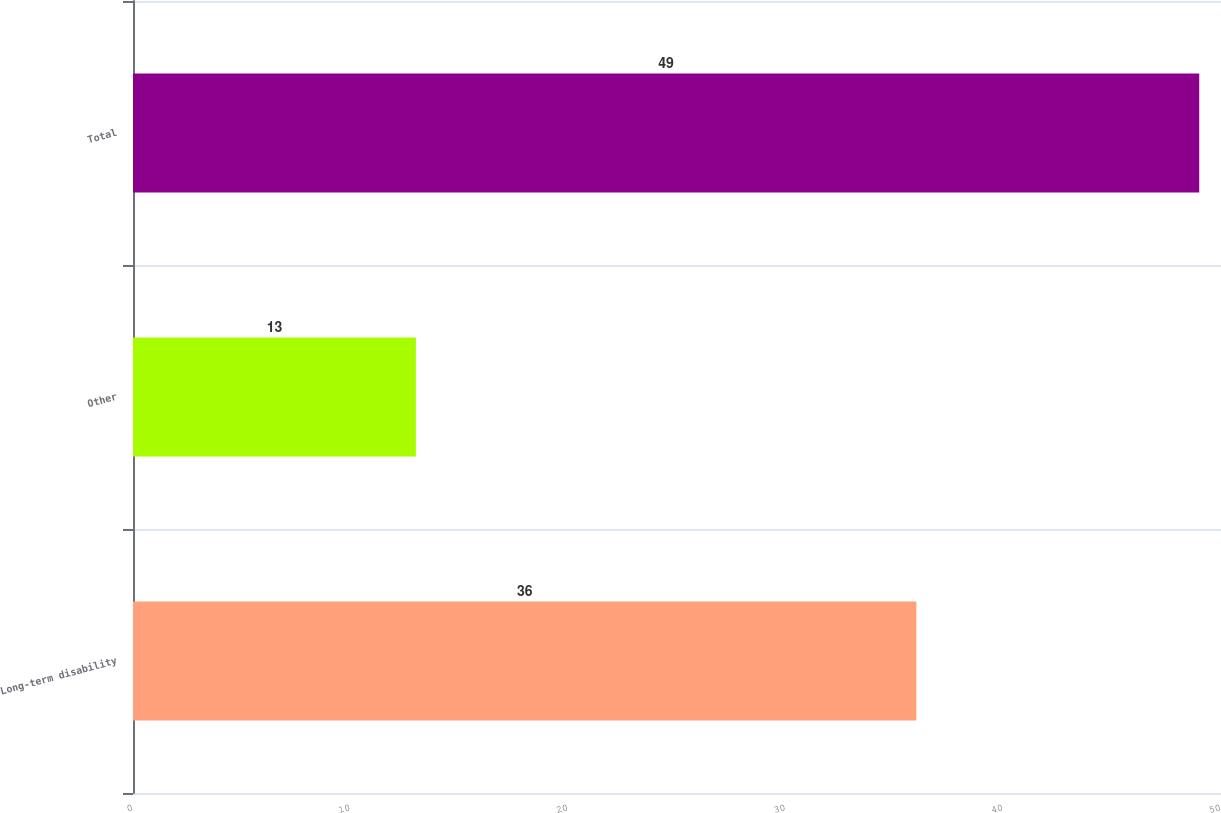<chart> <loc_0><loc_0><loc_500><loc_500><bar_chart><fcel>Long-term disability<fcel>Other<fcel>Total<nl><fcel>36<fcel>13<fcel>49<nl></chart> 